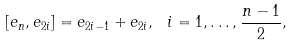<formula> <loc_0><loc_0><loc_500><loc_500>[ e _ { n } , e _ { 2 i } ] = e _ { 2 i - 1 } + e _ { 2 i } , \ i = 1 , \dots , \frac { n - 1 } { 2 } ,</formula> 